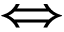Convert formula to latex. <formula><loc_0><loc_0><loc_500><loc_500>\Longleftrightarrow</formula> 